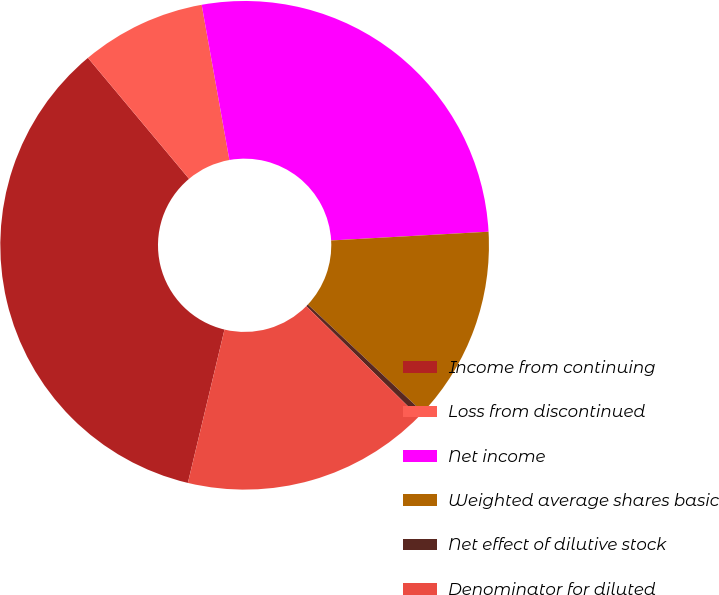Convert chart. <chart><loc_0><loc_0><loc_500><loc_500><pie_chart><fcel>Income from continuing<fcel>Loss from discontinued<fcel>Net income<fcel>Weighted average shares basic<fcel>Net effect of dilutive stock<fcel>Denominator for diluted<nl><fcel>35.19%<fcel>8.27%<fcel>26.93%<fcel>12.87%<fcel>0.4%<fcel>16.35%<nl></chart> 